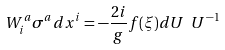Convert formula to latex. <formula><loc_0><loc_0><loc_500><loc_500>W _ { i } ^ { a } \sigma ^ { a } d x ^ { i } = - \frac { 2 i } { g } f ( \xi ) d U \ U ^ { - 1 }</formula> 